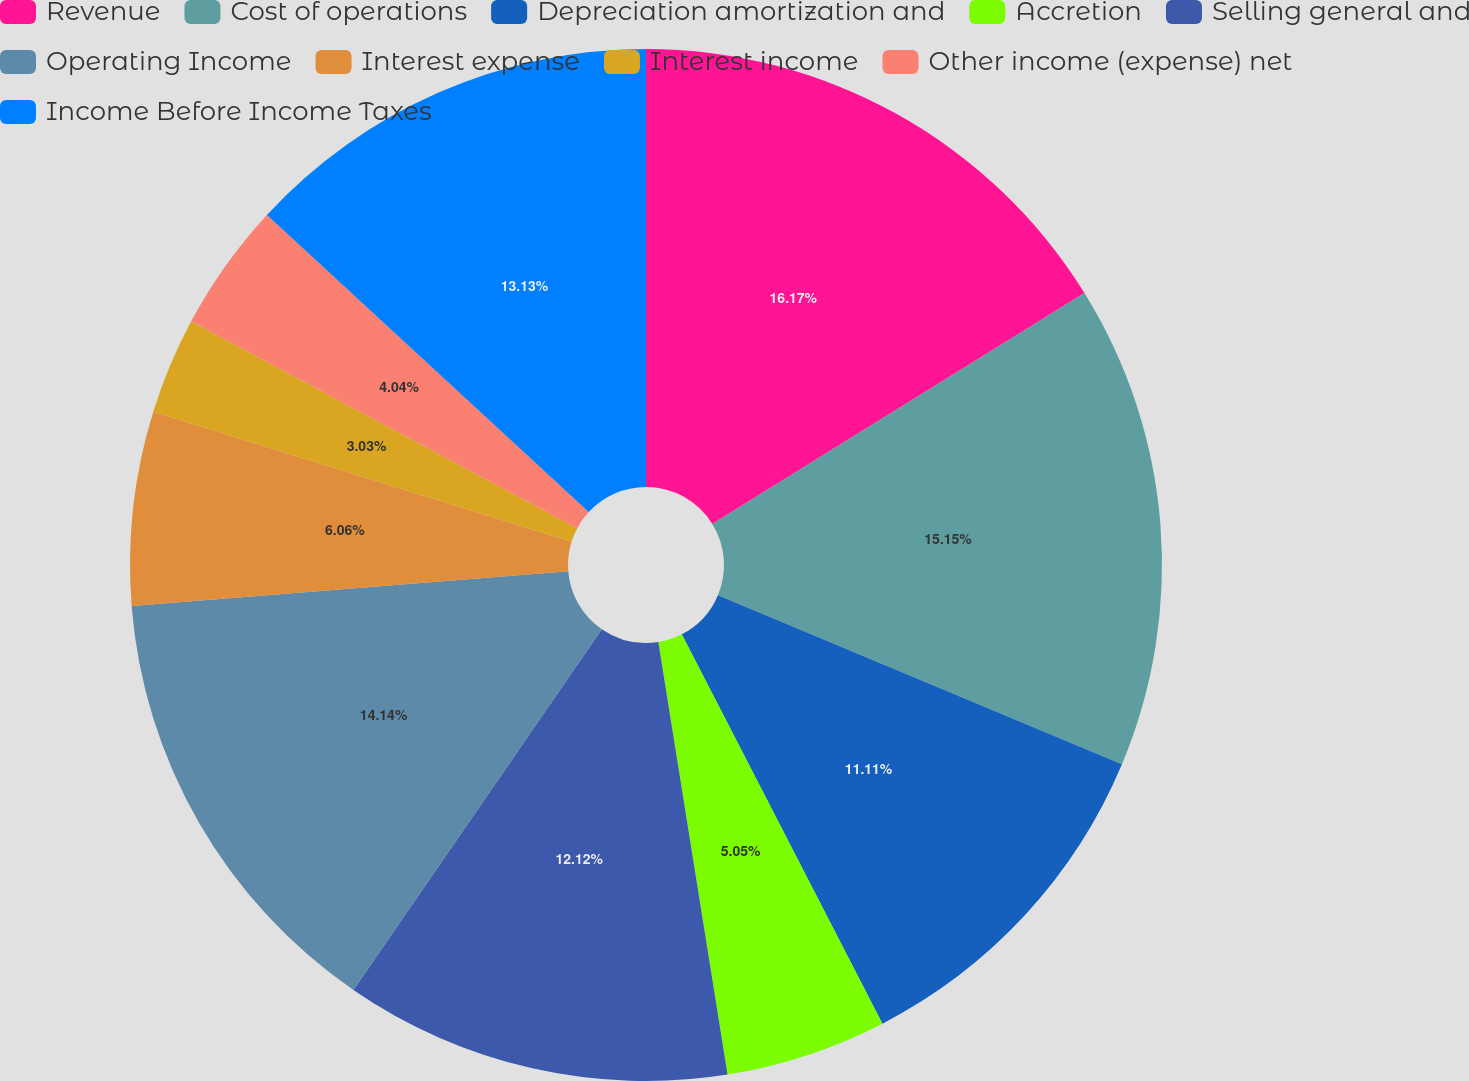Convert chart. <chart><loc_0><loc_0><loc_500><loc_500><pie_chart><fcel>Revenue<fcel>Cost of operations<fcel>Depreciation amortization and<fcel>Accretion<fcel>Selling general and<fcel>Operating Income<fcel>Interest expense<fcel>Interest income<fcel>Other income (expense) net<fcel>Income Before Income Taxes<nl><fcel>16.16%<fcel>15.15%<fcel>11.11%<fcel>5.05%<fcel>12.12%<fcel>14.14%<fcel>6.06%<fcel>3.03%<fcel>4.04%<fcel>13.13%<nl></chart> 